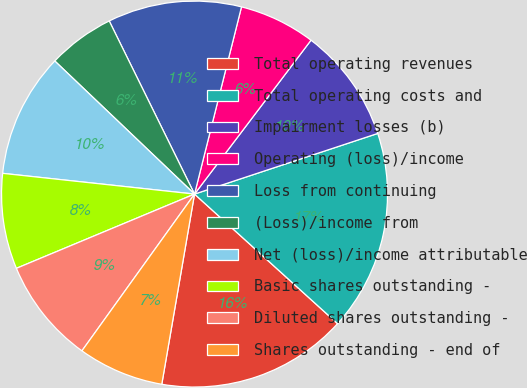Convert chart to OTSL. <chart><loc_0><loc_0><loc_500><loc_500><pie_chart><fcel>Total operating revenues<fcel>Total operating costs and<fcel>Impairment losses (b)<fcel>Operating (loss)/income<fcel>Loss from continuing<fcel>(Loss)/income from<fcel>Net (loss)/income attributable<fcel>Basic shares outstanding -<fcel>Diluted shares outstanding -<fcel>Shares outstanding - end of<nl><fcel>16.0%<fcel>16.8%<fcel>9.6%<fcel>6.4%<fcel>11.2%<fcel>5.6%<fcel>10.4%<fcel>8.0%<fcel>8.8%<fcel>7.2%<nl></chart> 